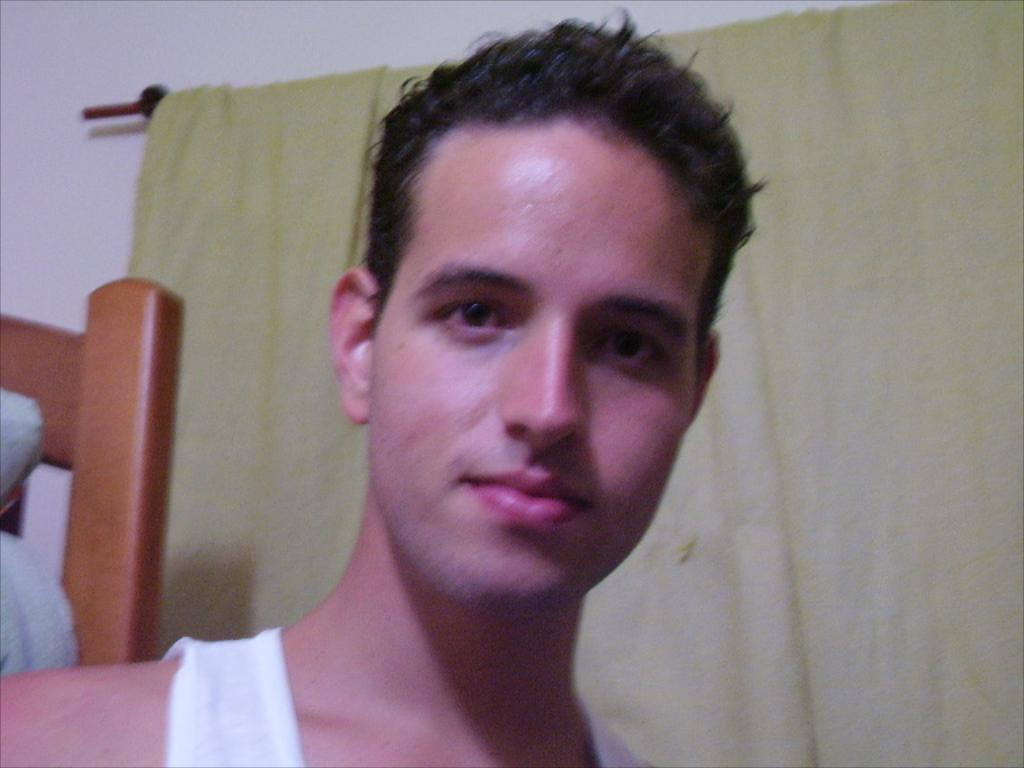What is present in the image? There is a person in the image. What can be seen behind the person? There is brown color wooden furniture behind the person. What color is the curtain in the image? There is a green color curtain in the image. What is visible in the background of the image? There is a wall in the background of the image. What is the manager's role in the image? There is no mention of a manager in the image or the provided facts. 